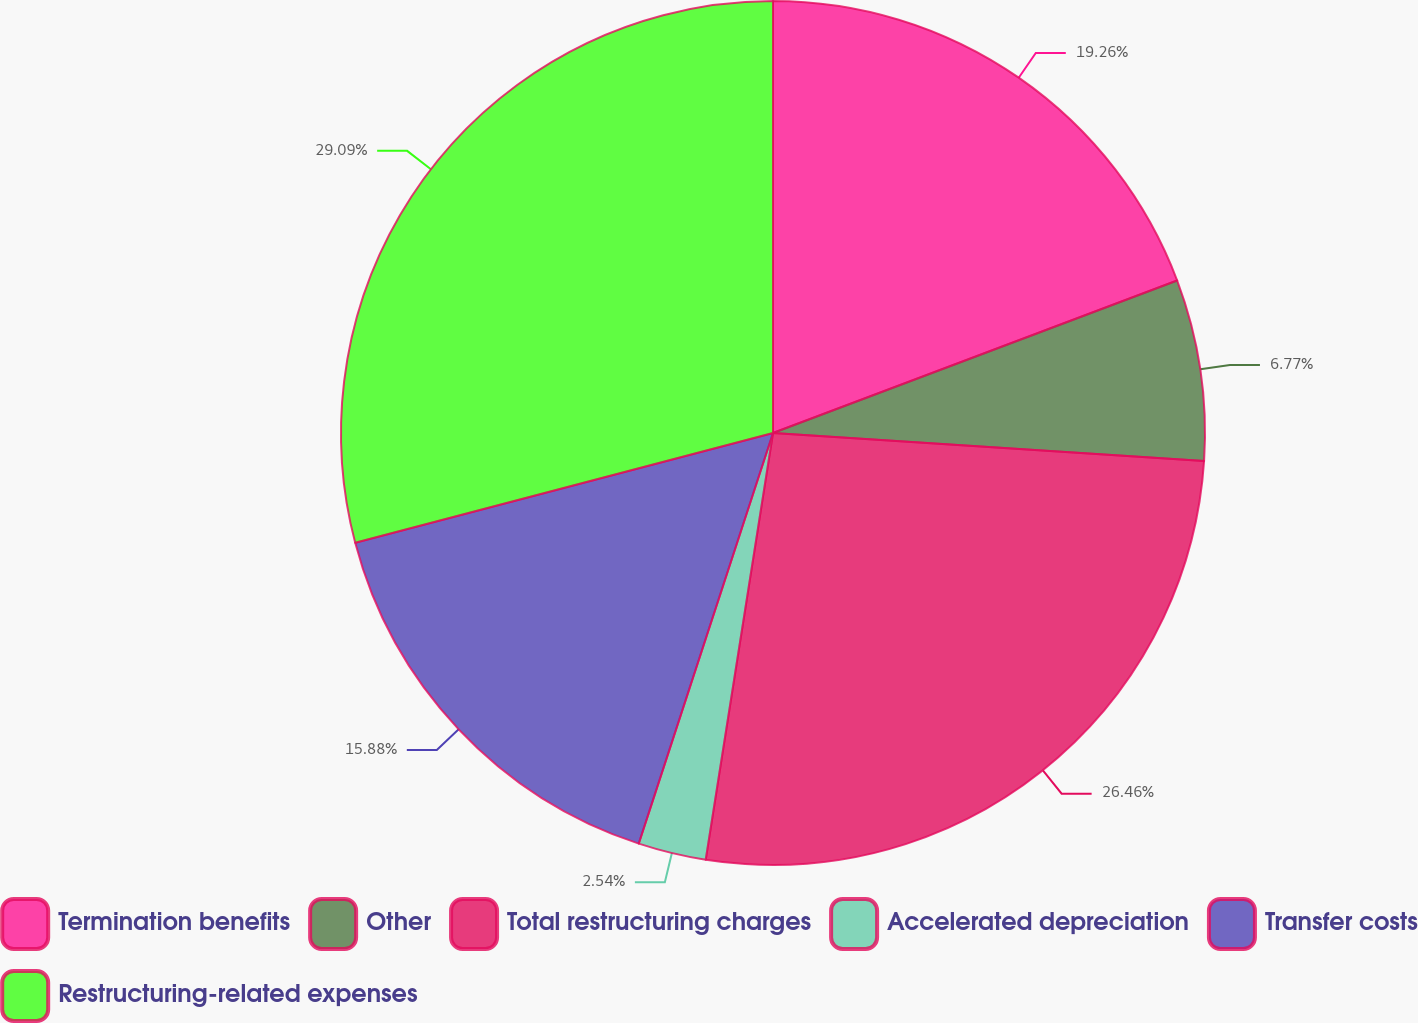Convert chart to OTSL. <chart><loc_0><loc_0><loc_500><loc_500><pie_chart><fcel>Termination benefits<fcel>Other<fcel>Total restructuring charges<fcel>Accelerated depreciation<fcel>Transfer costs<fcel>Restructuring-related expenses<nl><fcel>19.26%<fcel>6.77%<fcel>26.46%<fcel>2.54%<fcel>15.88%<fcel>29.09%<nl></chart> 